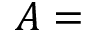<formula> <loc_0><loc_0><loc_500><loc_500>A =</formula> 